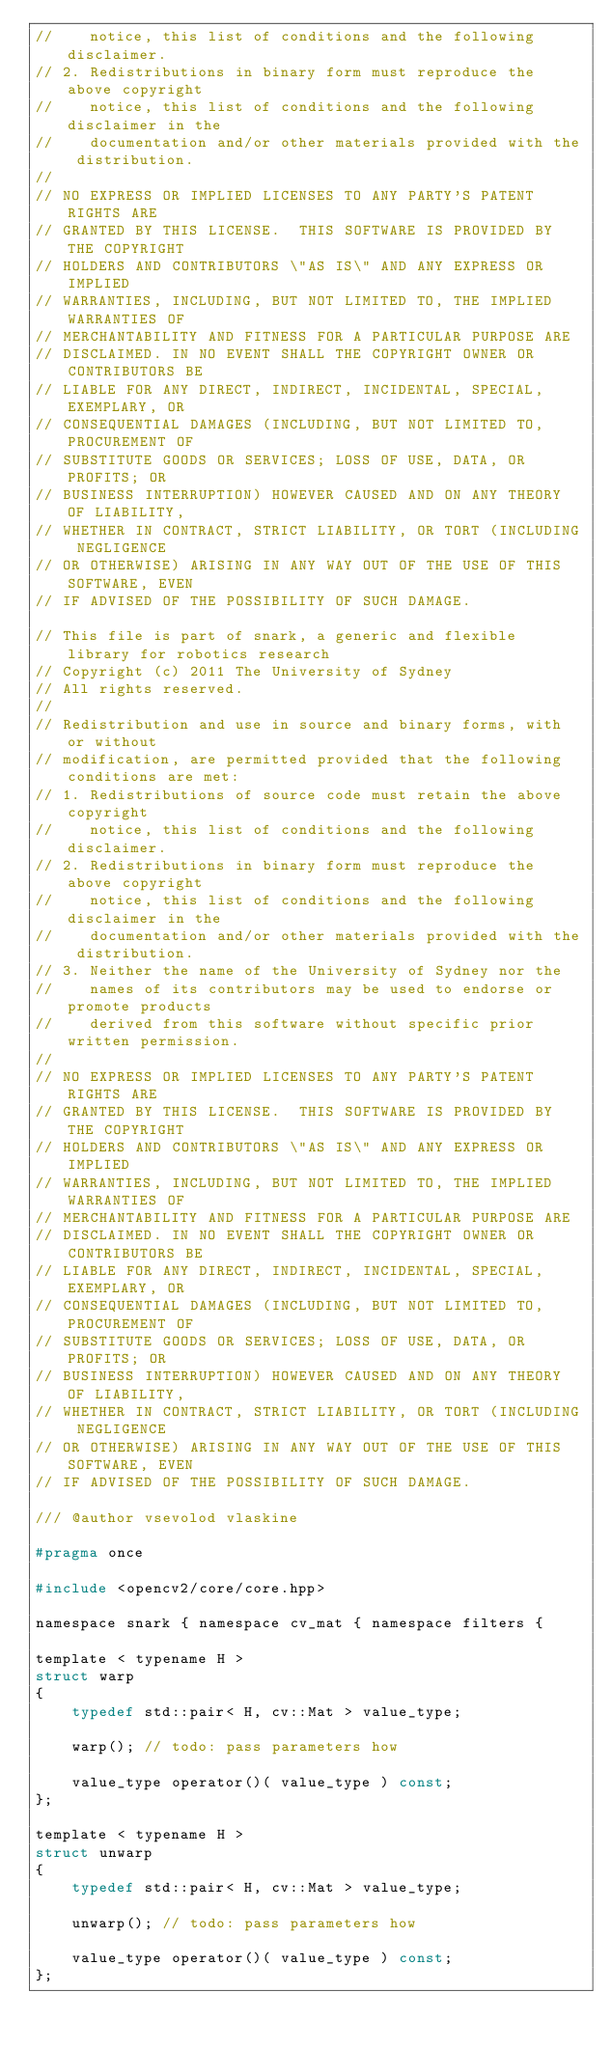<code> <loc_0><loc_0><loc_500><loc_500><_C_>//    notice, this list of conditions and the following disclaimer.
// 2. Redistributions in binary form must reproduce the above copyright
//    notice, this list of conditions and the following disclaimer in the
//    documentation and/or other materials provided with the distribution.
//
// NO EXPRESS OR IMPLIED LICENSES TO ANY PARTY'S PATENT RIGHTS ARE
// GRANTED BY THIS LICENSE.  THIS SOFTWARE IS PROVIDED BY THE COPYRIGHT
// HOLDERS AND CONTRIBUTORS \"AS IS\" AND ANY EXPRESS OR IMPLIED
// WARRANTIES, INCLUDING, BUT NOT LIMITED TO, THE IMPLIED WARRANTIES OF
// MERCHANTABILITY AND FITNESS FOR A PARTICULAR PURPOSE ARE
// DISCLAIMED. IN NO EVENT SHALL THE COPYRIGHT OWNER OR CONTRIBUTORS BE
// LIABLE FOR ANY DIRECT, INDIRECT, INCIDENTAL, SPECIAL, EXEMPLARY, OR
// CONSEQUENTIAL DAMAGES (INCLUDING, BUT NOT LIMITED TO, PROCUREMENT OF
// SUBSTITUTE GOODS OR SERVICES; LOSS OF USE, DATA, OR PROFITS; OR
// BUSINESS INTERRUPTION) HOWEVER CAUSED AND ON ANY THEORY OF LIABILITY,
// WHETHER IN CONTRACT, STRICT LIABILITY, OR TORT (INCLUDING NEGLIGENCE
// OR OTHERWISE) ARISING IN ANY WAY OUT OF THE USE OF THIS SOFTWARE, EVEN
// IF ADVISED OF THE POSSIBILITY OF SUCH DAMAGE.

// This file is part of snark, a generic and flexible library for robotics research
// Copyright (c) 2011 The University of Sydney
// All rights reserved.
//
// Redistribution and use in source and binary forms, with or without
// modification, are permitted provided that the following conditions are met:
// 1. Redistributions of source code must retain the above copyright
//    notice, this list of conditions and the following disclaimer.
// 2. Redistributions in binary form must reproduce the above copyright
//    notice, this list of conditions and the following disclaimer in the
//    documentation and/or other materials provided with the distribution.
// 3. Neither the name of the University of Sydney nor the
//    names of its contributors may be used to endorse or promote products
//    derived from this software without specific prior written permission.
//
// NO EXPRESS OR IMPLIED LICENSES TO ANY PARTY'S PATENT RIGHTS ARE
// GRANTED BY THIS LICENSE.  THIS SOFTWARE IS PROVIDED BY THE COPYRIGHT
// HOLDERS AND CONTRIBUTORS \"AS IS\" AND ANY EXPRESS OR IMPLIED
// WARRANTIES, INCLUDING, BUT NOT LIMITED TO, THE IMPLIED WARRANTIES OF
// MERCHANTABILITY AND FITNESS FOR A PARTICULAR PURPOSE ARE
// DISCLAIMED. IN NO EVENT SHALL THE COPYRIGHT OWNER OR CONTRIBUTORS BE
// LIABLE FOR ANY DIRECT, INDIRECT, INCIDENTAL, SPECIAL, EXEMPLARY, OR
// CONSEQUENTIAL DAMAGES (INCLUDING, BUT NOT LIMITED TO, PROCUREMENT OF
// SUBSTITUTE GOODS OR SERVICES; LOSS OF USE, DATA, OR PROFITS; OR
// BUSINESS INTERRUPTION) HOWEVER CAUSED AND ON ANY THEORY OF LIABILITY,
// WHETHER IN CONTRACT, STRICT LIABILITY, OR TORT (INCLUDING NEGLIGENCE
// OR OTHERWISE) ARISING IN ANY WAY OUT OF THE USE OF THIS SOFTWARE, EVEN
// IF ADVISED OF THE POSSIBILITY OF SUCH DAMAGE.

/// @author vsevolod vlaskine

#pragma once

#include <opencv2/core/core.hpp>

namespace snark { namespace cv_mat { namespace filters {

template < typename H >
struct warp
{
    typedef std::pair< H, cv::Mat > value_type;

    warp(); // todo: pass parameters how

    value_type operator()( value_type ) const;
};

template < typename H >
struct unwarp
{
    typedef std::pair< H, cv::Mat > value_type;
    
    unwarp(); // todo: pass parameters how

    value_type operator()( value_type ) const;
};
</code> 